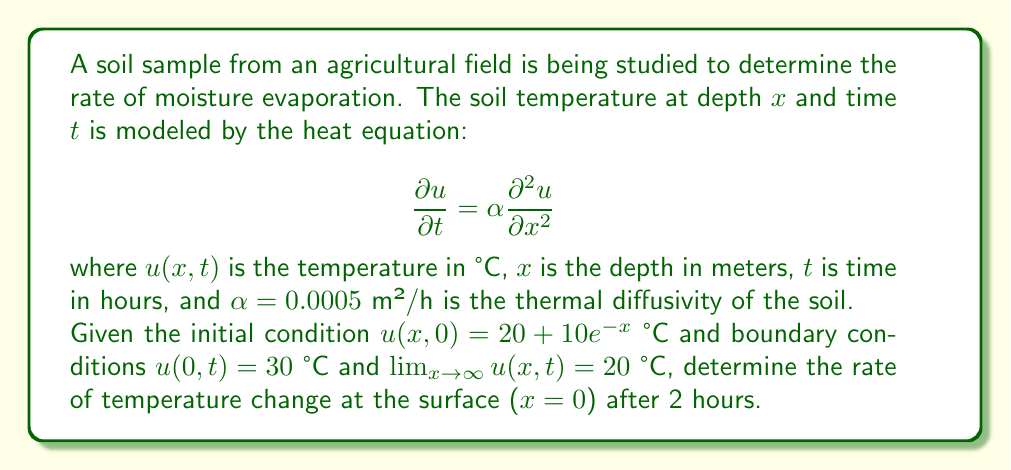Could you help me with this problem? To solve this problem, we need to follow these steps:

1) The general solution to the heat equation with the given boundary conditions is:

   $$u(x,t) = 20 + 10e^{-x}\text{erfc}\left(\frac{x}{2\sqrt{\alpha t}}\right)$$

   where erfc is the complementary error function.

2) To find the rate of temperature change at the surface, we need to calculate $\frac{\partial u}{\partial t}$ at $x=0$ and $t=2$.

3) First, let's differentiate $u(x,t)$ with respect to $t$:

   $$\frac{\partial u}{\partial t} = 10e^{-x} \cdot \frac{\partial}{\partial t}\text{erfc}\left(\frac{x}{2\sqrt{\alpha t}}\right)$$

4) Using the chain rule and the fact that $\frac{d}{dy}\text{erfc}(y) = -\frac{2}{\sqrt{\pi}}e^{-y^2}$, we get:

   $$\frac{\partial u}{\partial t} = 10e^{-x} \cdot \left(-\frac{2}{\sqrt{\pi}}e^{-\frac{x^2}{4\alpha t}}\right) \cdot \left(-\frac{x}{4\sqrt{\alpha}t^{3/2}}\right)$$

5) Simplifying:

   $$\frac{\partial u}{\partial t} = \frac{5x}{\sqrt{\pi\alpha}t^{3/2}}e^{-x-\frac{x^2}{4\alpha t}}$$

6) Now, we evaluate this at $x=0$ and $t=2$:

   $$\left.\frac{\partial u}{\partial t}\right|_{x=0,t=2} = \frac{5 \cdot 0}{\sqrt{\pi \cdot 0.0005} \cdot 2^{3/2}}e^{-0-\frac{0^2}{4 \cdot 0.0005 \cdot 2}} = 0$$

7) Therefore, the rate of temperature change at the surface after 2 hours is 0 °C/h.
Answer: 0 °C/h 